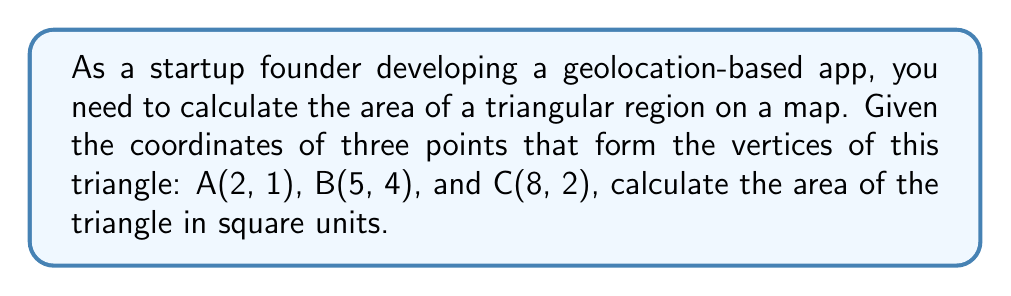Help me with this question. To calculate the area of a triangle given the coordinates of its vertices, we can use the following formula:

$$\text{Area} = \frac{1}{2}|x_1(y_2 - y_3) + x_2(y_3 - y_1) + x_3(y_1 - y_2)|$$

Where $(x_1, y_1)$, $(x_2, y_2)$, and $(x_3, y_3)$ are the coordinates of the three vertices.

Let's follow these steps:

1. Identify the coordinates:
   A: $(x_1, y_1) = (2, 1)$
   B: $(x_2, y_2) = (5, 4)$
   C: $(x_3, y_3) = (8, 2)$

2. Substitute these values into the formula:

   $$\text{Area} = \frac{1}{2}|2(4 - 2) + 5(2 - 1) + 8(1 - 4)|$$

3. Simplify the expressions inside the parentheses:

   $$\text{Area} = \frac{1}{2}|2(2) + 5(1) + 8(-3)|$$

4. Multiply:

   $$\text{Area} = \frac{1}{2}|4 + 5 - 24|$$

5. Add the terms inside the absolute value signs:

   $$\text{Area} = \frac{1}{2}|-15|$$

6. Calculate the absolute value:

   $$\text{Area} = \frac{1}{2}(15)$$

7. Simplify:

   $$\text{Area} = 7.5$$

Therefore, the area of the triangle is 7.5 square units.

[asy]
unitsize(20);
dot((2,1));
dot((5,4));
dot((8,2));
draw((2,1)--(5,4)--(8,2)--cycle);
label("A(2,1)", (2,1), SW);
label("B(5,4)", (5,4), N);
label("C(8,2)", (8,2), SE);
[/asy]
Answer: The area of the triangle is 7.5 square units. 